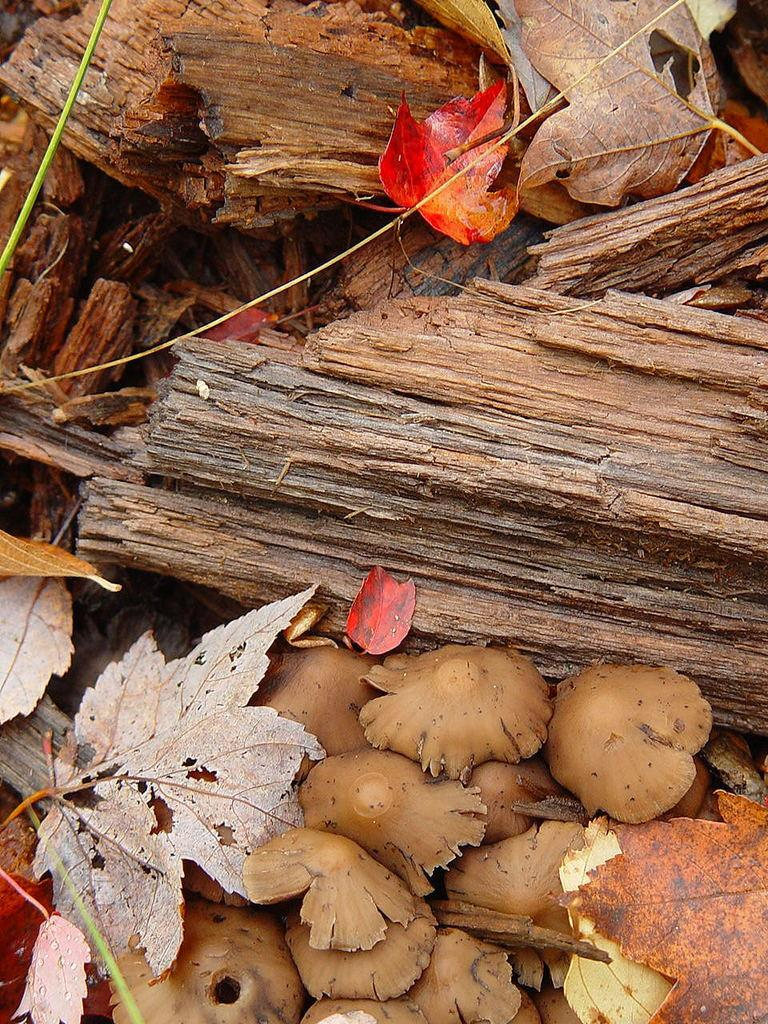What type of objects are made of wood in the image? There are wooden sticks in the image. What type of plant material is present in the image? There are leaves in the image. What type of fungi can be seen in the image? There are mushrooms in the image. What type of cheese is hanging from the hook in the image? There is no cheese or hook present in the image. What type of servant can be seen attending to the mushrooms in the image? There is no servant present in the image; it only features wooden sticks, leaves, and mushrooms. 